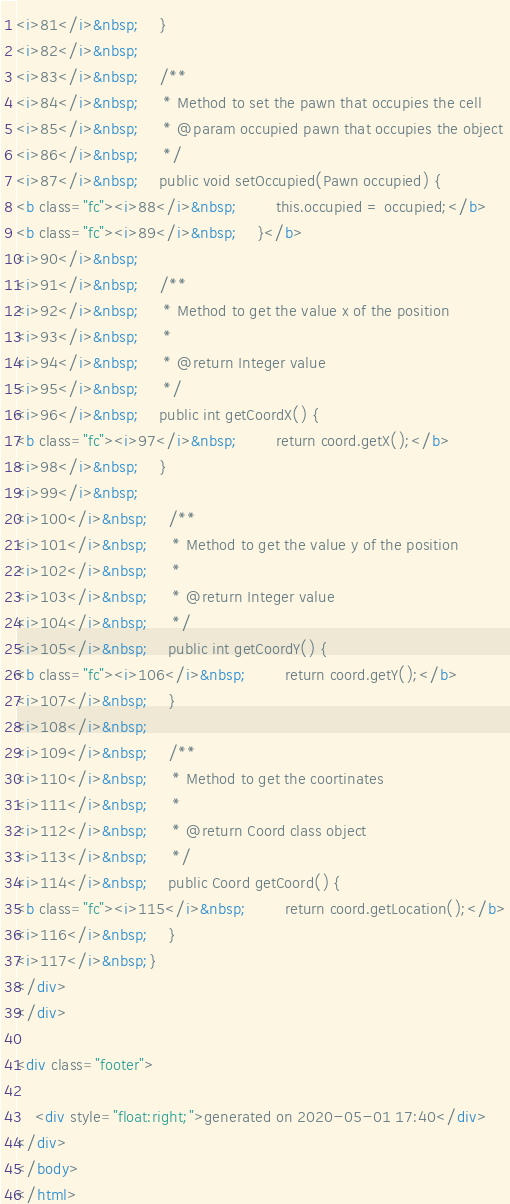Convert code to text. <code><loc_0><loc_0><loc_500><loc_500><_HTML_><i>81</i>&nbsp;    }
<i>82</i>&nbsp;
<i>83</i>&nbsp;    /**
<i>84</i>&nbsp;     * Method to set the pawn that occupies the cell
<i>85</i>&nbsp;     * @param occupied pawn that occupies the object
<i>86</i>&nbsp;     */
<i>87</i>&nbsp;    public void setOccupied(Pawn occupied) {
<b class="fc"><i>88</i>&nbsp;        this.occupied = occupied;</b>
<b class="fc"><i>89</i>&nbsp;    }</b>
<i>90</i>&nbsp;
<i>91</i>&nbsp;    /**
<i>92</i>&nbsp;     * Method to get the value x of the position
<i>93</i>&nbsp;     *
<i>94</i>&nbsp;     * @return Integer value
<i>95</i>&nbsp;     */
<i>96</i>&nbsp;    public int getCoordX() {
<b class="fc"><i>97</i>&nbsp;        return coord.getX();</b>
<i>98</i>&nbsp;    }
<i>99</i>&nbsp;
<i>100</i>&nbsp;    /**
<i>101</i>&nbsp;     * Method to get the value y of the position
<i>102</i>&nbsp;     *
<i>103</i>&nbsp;     * @return Integer value
<i>104</i>&nbsp;     */
<i>105</i>&nbsp;    public int getCoordY() {
<b class="fc"><i>106</i>&nbsp;        return coord.getY();</b>
<i>107</i>&nbsp;    }
<i>108</i>&nbsp;
<i>109</i>&nbsp;    /**
<i>110</i>&nbsp;     * Method to get the coortinates
<i>111</i>&nbsp;     *
<i>112</i>&nbsp;     * @return Coord class object
<i>113</i>&nbsp;     */
<i>114</i>&nbsp;    public Coord getCoord() {
<b class="fc"><i>115</i>&nbsp;        return coord.getLocation();</b>
<i>116</i>&nbsp;    }
<i>117</i>&nbsp;}
</div>
</div>

<div class="footer">
    
    <div style="float:right;">generated on 2020-05-01 17:40</div>
</div>
</body>
</html>
</code> 